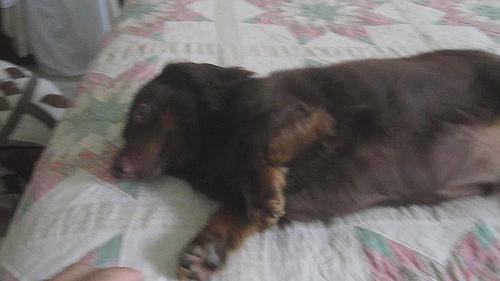How many dogs are there?
Give a very brief answer. 1. 